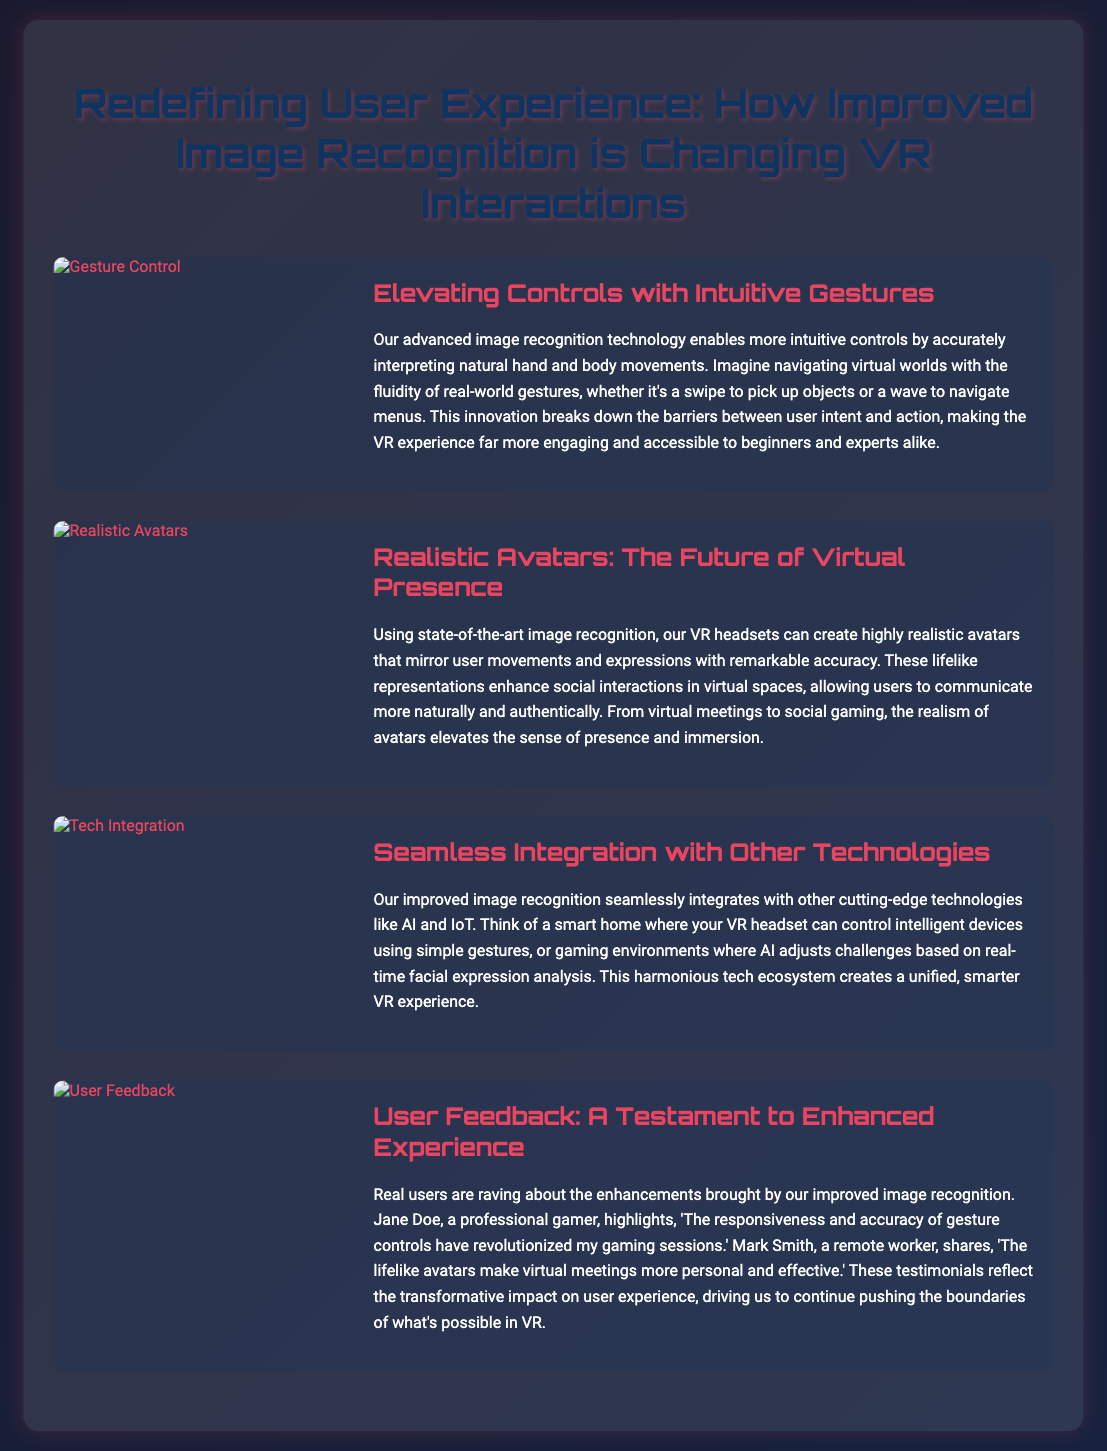What is the main focus of the flyer? The flyer focuses on how improved image recognition is changing VR interactions and enhancing user experience.
Answer: Improved image recognition Who benefits from intuitive gesture controls? The document states that intuitive gesture controls benefit both beginners and experts.
Answer: Beginners and experts What will highly realistic avatars enhance? The highly realistic avatars will enhance social interactions in virtual spaces.
Answer: Social interactions Which two technologies seamlessly integrate with image recognition? The two technologies are AI and IoT as mentioned in the flyer.
Answer: AI and IoT What did Jane Doe highlight about gesture controls? Jane Doe highlighted that their responsiveness and accuracy have revolutionized her gaming sessions.
Answer: Revolutionized my gaming sessions What kind of ecosystem does improved image recognition create? It creates a unified and smarter VR experience.
Answer: Unified and smarter VR experience What aspect of user experience is emphasized in user feedback? The user feedback emphasizes the transformative impact on user experience.
Answer: Transformative impact How does improved image recognition make virtual meetings? Improved image recognition makes virtual meetings more personal and effective.
Answer: More personal and effective What two features are highlighted in the section about realistic avatars? The two features highlighted are mirroring user movements and expressions with remarkable accuracy.
Answer: Mirroring user movements and expressions 